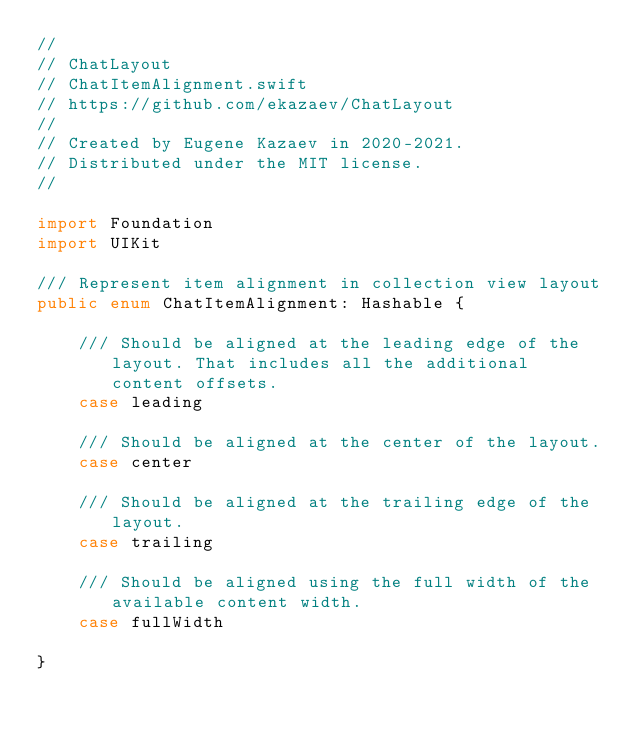Convert code to text. <code><loc_0><loc_0><loc_500><loc_500><_Swift_>//
// ChatLayout
// ChatItemAlignment.swift
// https://github.com/ekazaev/ChatLayout
//
// Created by Eugene Kazaev in 2020-2021.
// Distributed under the MIT license.
//

import Foundation
import UIKit

/// Represent item alignment in collection view layout
public enum ChatItemAlignment: Hashable {

    /// Should be aligned at the leading edge of the layout. That includes all the additional content offsets.
    case leading

    /// Should be aligned at the center of the layout.
    case center

    /// Should be aligned at the trailing edge of the layout.
    case trailing

    /// Should be aligned using the full width of the available content width.
    case fullWidth

}
</code> 